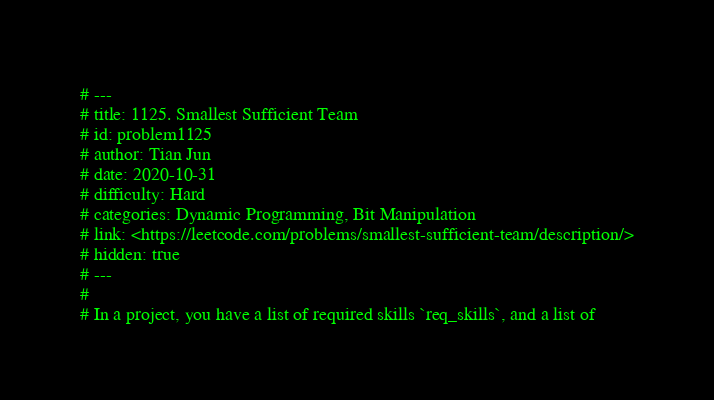Convert code to text. <code><loc_0><loc_0><loc_500><loc_500><_Julia_># ---
# title: 1125. Smallest Sufficient Team
# id: problem1125
# author: Tian Jun
# date: 2020-10-31
# difficulty: Hard
# categories: Dynamic Programming, Bit Manipulation
# link: <https://leetcode.com/problems/smallest-sufficient-team/description/>
# hidden: true
# ---
# 
# In a project, you have a list of required skills `req_skills`, and a list of</code> 